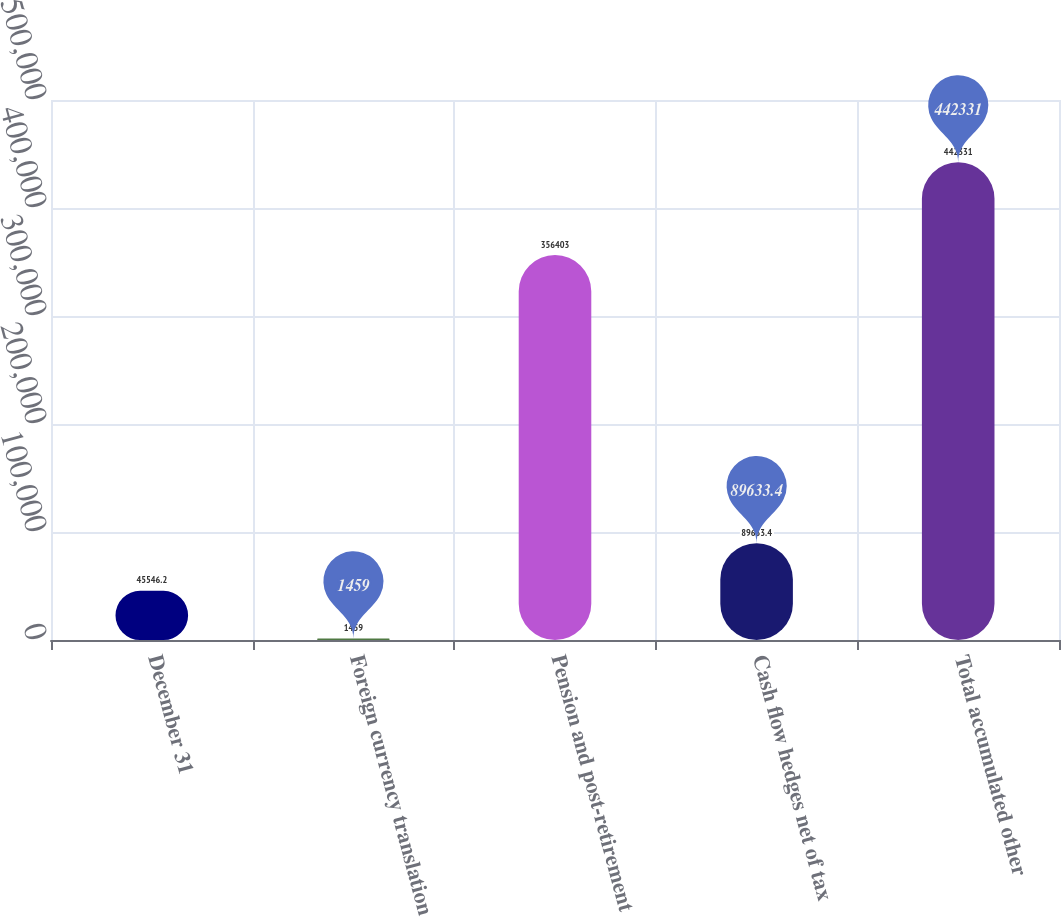Convert chart to OTSL. <chart><loc_0><loc_0><loc_500><loc_500><bar_chart><fcel>December 31<fcel>Foreign currency translation<fcel>Pension and post-retirement<fcel>Cash flow hedges net of tax<fcel>Total accumulated other<nl><fcel>45546.2<fcel>1459<fcel>356403<fcel>89633.4<fcel>442331<nl></chart> 